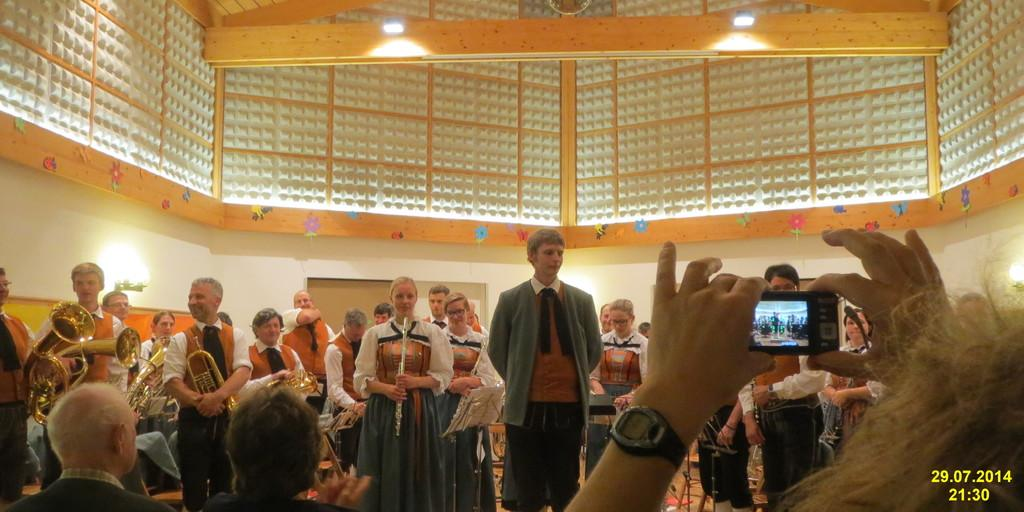<image>
Share a concise interpretation of the image provided. The video shown was recorded on 29/ of July in 2014. 